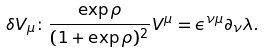<formula> <loc_0><loc_0><loc_500><loc_500>\delta V _ { \mu } \colon \frac { \exp \rho } { ( 1 + \exp \rho ) ^ { 2 } } V ^ { \mu } = \epsilon ^ { \nu \mu } \partial _ { \nu } \lambda .</formula> 